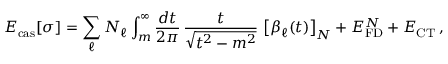<formula> <loc_0><loc_0><loc_500><loc_500>E _ { c a s } [ \sigma ] = \sum _ { \ell } N _ { \ell } \int _ { m } ^ { \infty } \frac { d t } { 2 \pi } \, \frac { t } { \sqrt { t ^ { 2 } - m ^ { 2 } } } \, \left [ \beta _ { \ell } ( t ) \right ] _ { N } + E _ { F D } ^ { N } + E _ { C T } \, ,</formula> 